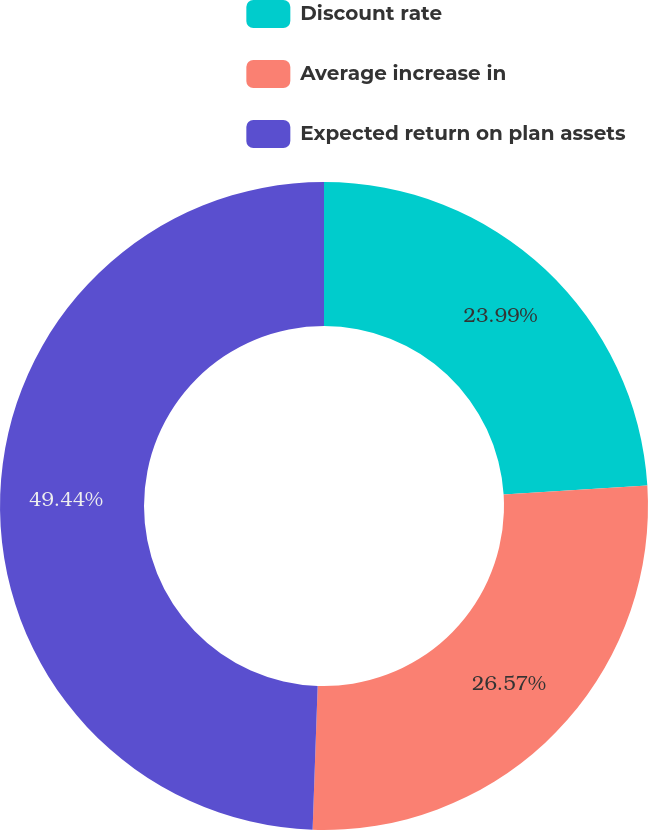Convert chart. <chart><loc_0><loc_0><loc_500><loc_500><pie_chart><fcel>Discount rate<fcel>Average increase in<fcel>Expected return on plan assets<nl><fcel>23.99%<fcel>26.57%<fcel>49.44%<nl></chart> 